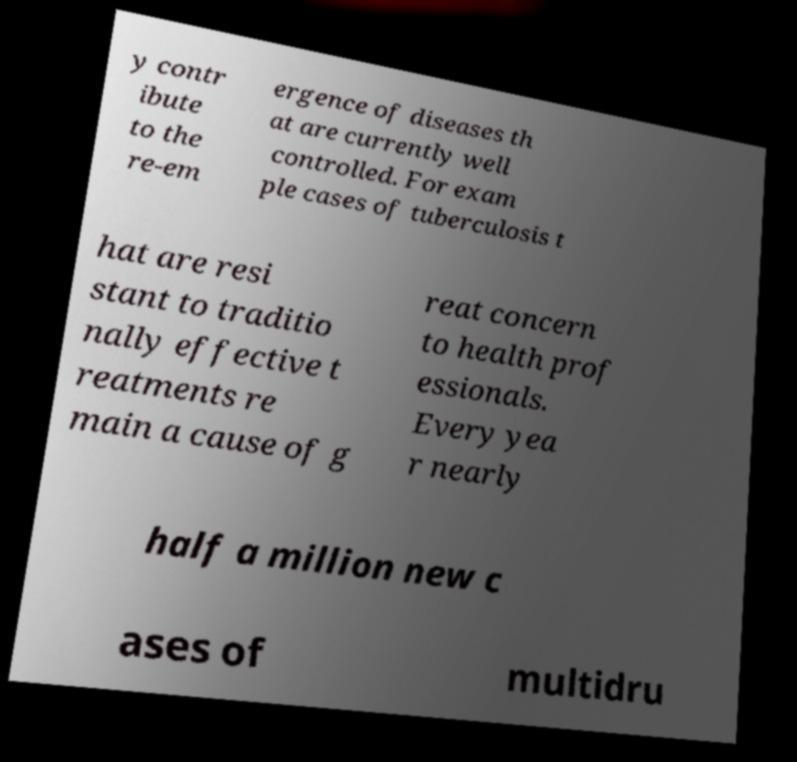For documentation purposes, I need the text within this image transcribed. Could you provide that? y contr ibute to the re-em ergence of diseases th at are currently well controlled. For exam ple cases of tuberculosis t hat are resi stant to traditio nally effective t reatments re main a cause of g reat concern to health prof essionals. Every yea r nearly half a million new c ases of multidru 